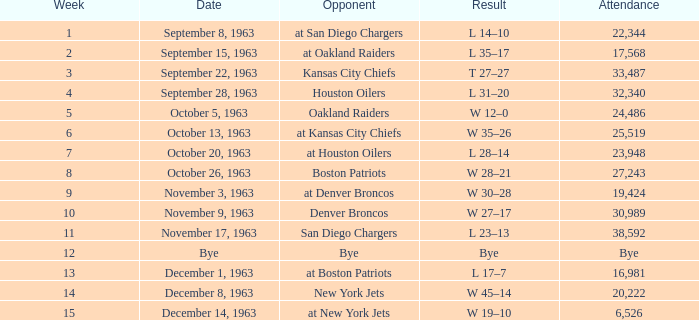Which adversary has a result of w 19-10? At new york jets. 